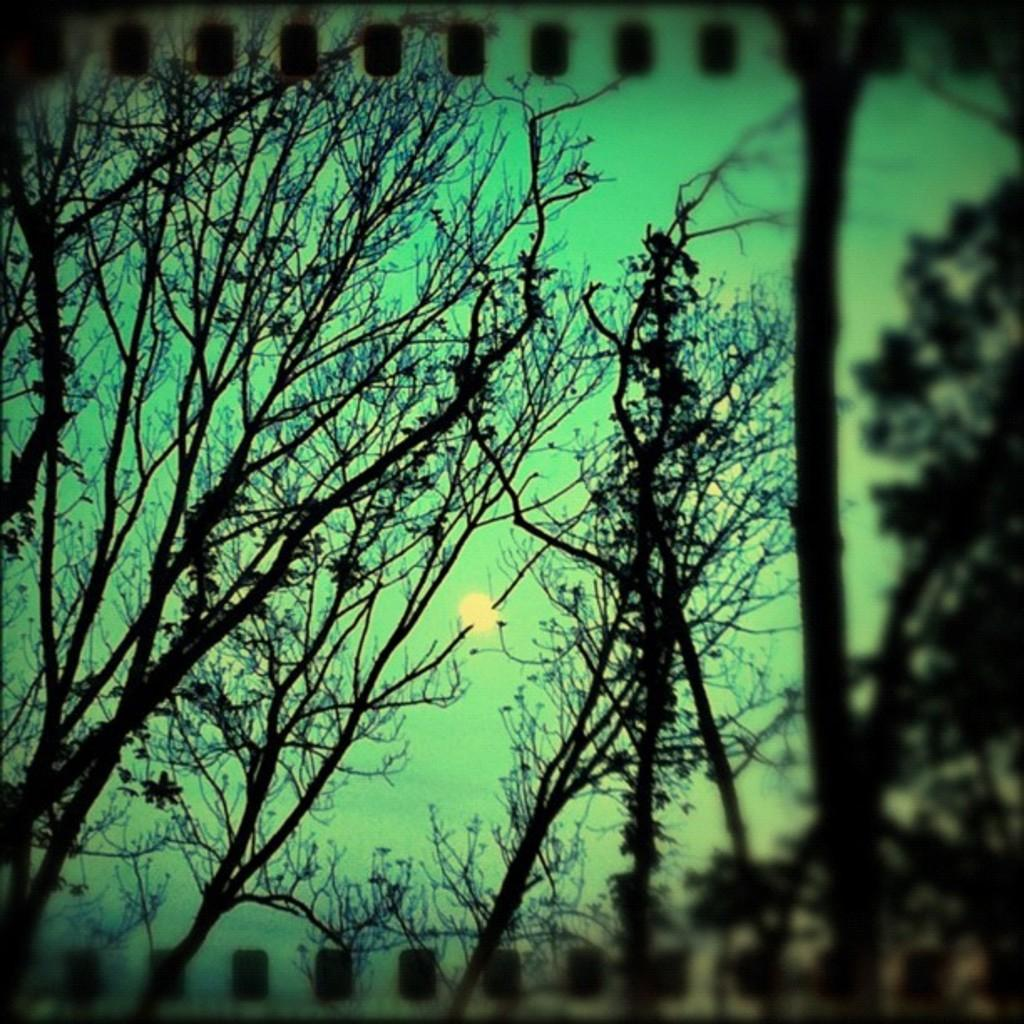What is the main subject of the image? The main subject of the image is a group of trees. What can be seen in the sky behind the trees? The sun is visible in the sky behind the trees. What type of drink is being offered by the trees in the image? There is no drink present in the image; it features a group of trees and the sun in the sky. 